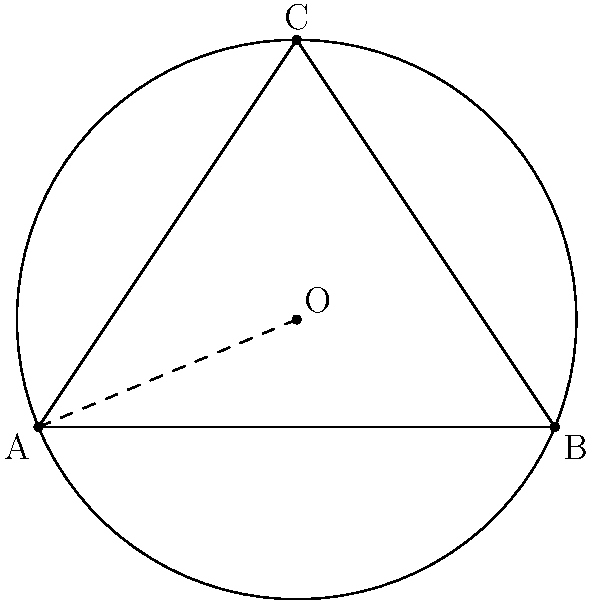Given three points on the circumference of a circle: $A(0,0)$, $B(4,0)$, and $C(2,3)$, determine the coordinates of the center $(x,y)$ and the radius $r$ of the circle. Express your answer as a tuple $(x,y,r)$, rounded to two decimal places. To find the center and radius of the circle, we'll follow these steps:

1) The center of the circle is the intersection point of the perpendicular bisectors of any two chords. We'll use AB and BC.

2) Midpoint of AB: $(\frac{0+4}{2}, \frac{0+0}{2}) = (2,0)$
   Slope of AB: $m_{AB} = \frac{0-0}{4-0} = 0$
   Perpendicular slope: $m_{\perp AB} = -\frac{1}{m_{AB}} = \infty$ (vertical line)
   Equation of perpendicular bisector of AB: $x = 2$

3) Midpoint of BC: $(\frac{4+2}{2}, \frac{0+3}{2}) = (3, 1.5)$
   Slope of BC: $m_{BC} = \frac{3-0}{2-4} = -\frac{3}{2}$
   Perpendicular slope: $m_{\perp BC} = \frac{2}{3}$
   Equation of perpendicular bisector of BC: $y - 1.5 = \frac{2}{3}(x - 3)$

4) Solve the system of equations:
   $x = 2$
   $y - 1.5 = \frac{2}{3}(x - 3)$

   Substituting $x = 2$ into the second equation:
   $y - 1.5 = \frac{2}{3}(2 - 3) = -\frac{2}{3}$
   $y = 1.5 - \frac{2}{3} = \frac{5}{6} \approx 0.83$

5) The center is at $(2, \frac{5}{6})$ or approximately $(2.00, 0.83)$

6) To find the radius, calculate the distance from the center to any of the given points:

   $r = \sqrt{(2-0)^2 + (\frac{5}{6}-0)^2} = \sqrt{4 + \frac{25}{36}} = \sqrt{\frac{169}{36}} = \frac{13}{6} \approx 2.17$

Therefore, the center coordinates and radius are approximately $(2.00, 0.83, 2.17)$.
Answer: $(2.00, 0.83, 2.17)$ 